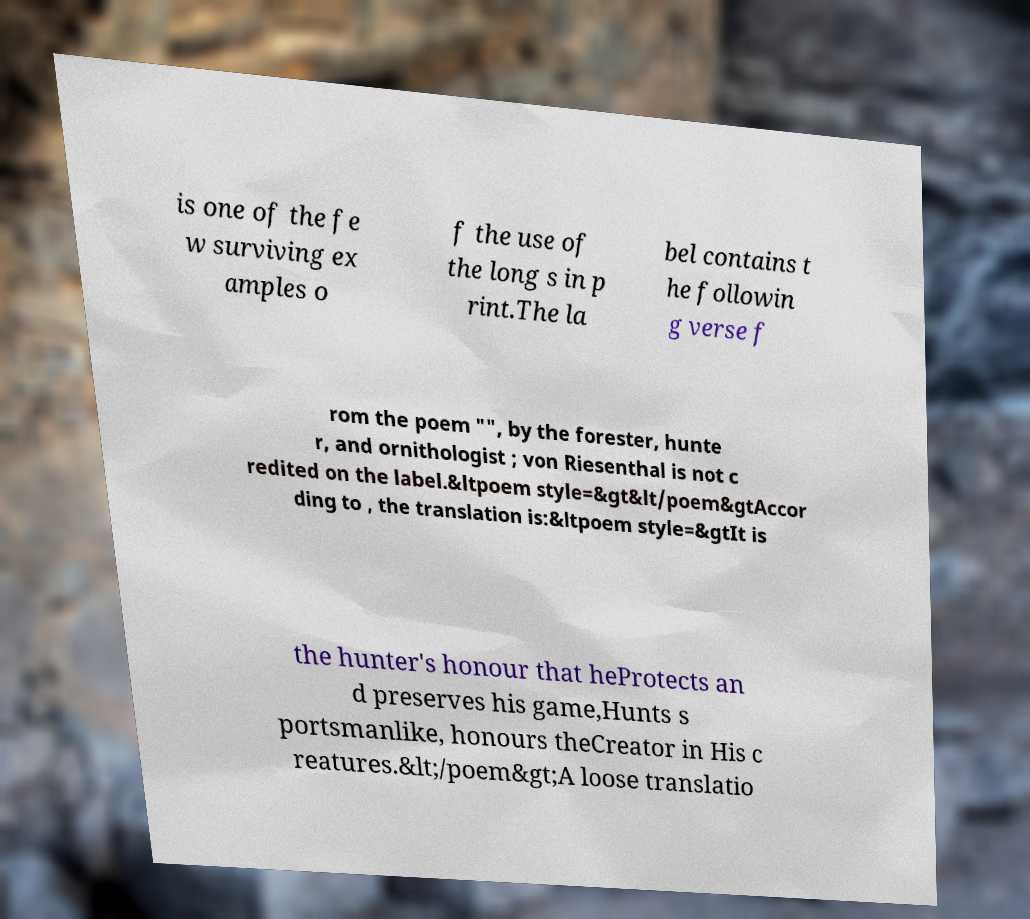Can you read and provide the text displayed in the image?This photo seems to have some interesting text. Can you extract and type it out for me? is one of the fe w surviving ex amples o f the use of the long s in p rint.The la bel contains t he followin g verse f rom the poem "", by the forester, hunte r, and ornithologist ; von Riesenthal is not c redited on the label.&ltpoem style=&gt&lt/poem&gtAccor ding to , the translation is:&ltpoem style=&gtIt is the hunter's honour that heProtects an d preserves his game,Hunts s portsmanlike, honours theCreator in His c reatures.&lt;/poem&gt;A loose translatio 